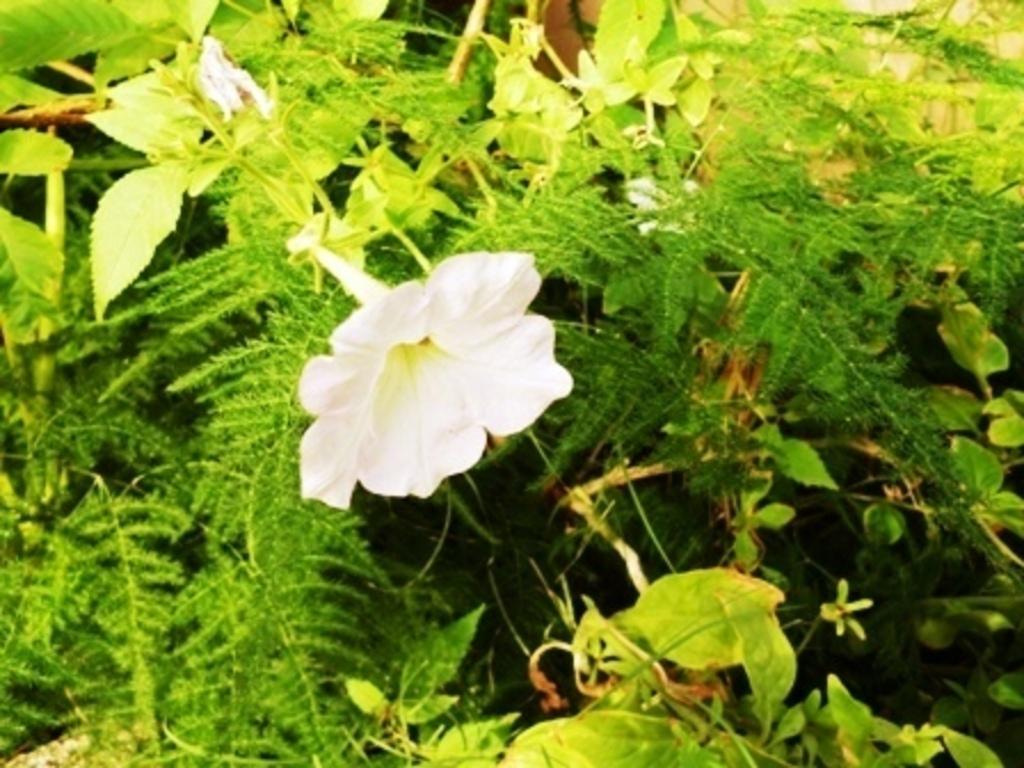Can you describe this image briefly? As we can see in the image there are plants and a white color flower. 